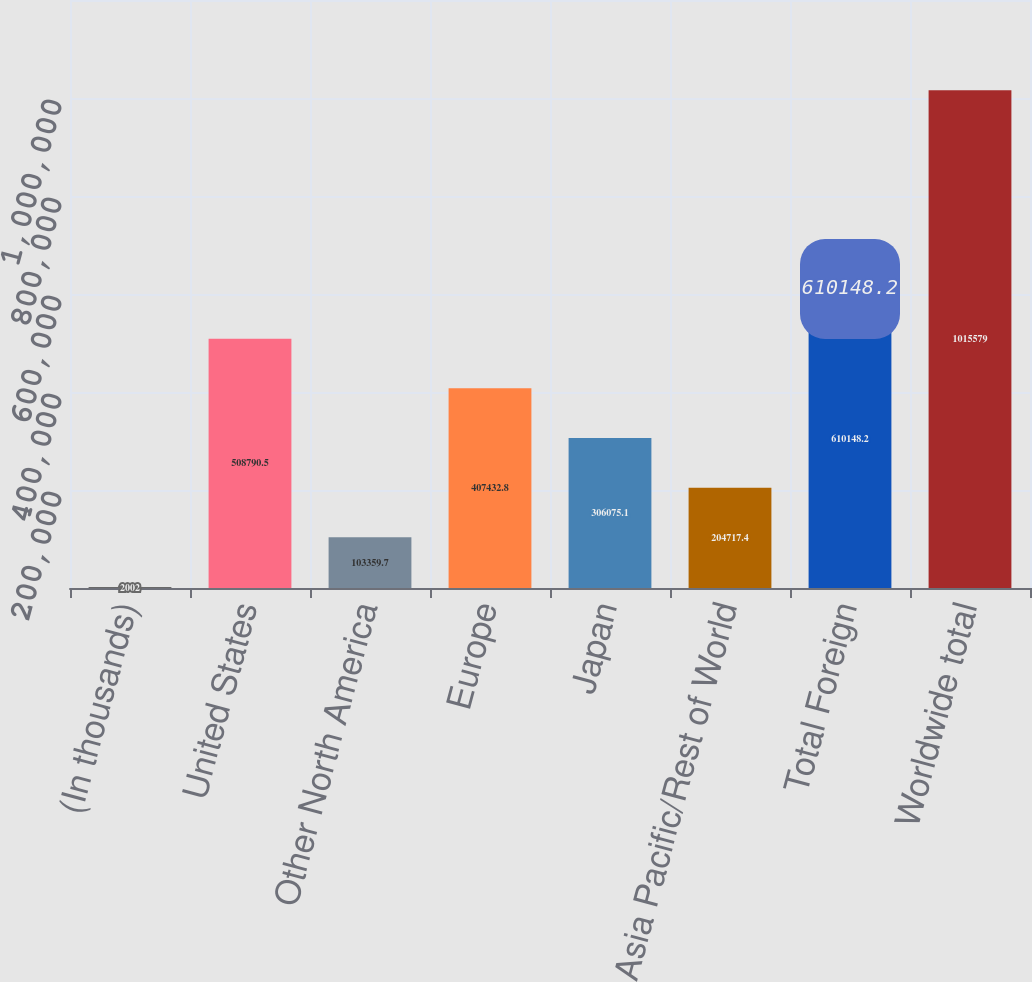Convert chart. <chart><loc_0><loc_0><loc_500><loc_500><bar_chart><fcel>(In thousands)<fcel>United States<fcel>Other North America<fcel>Europe<fcel>Japan<fcel>Asia Pacific/Rest of World<fcel>Total Foreign<fcel>Worldwide total<nl><fcel>2002<fcel>508790<fcel>103360<fcel>407433<fcel>306075<fcel>204717<fcel>610148<fcel>1.01558e+06<nl></chart> 